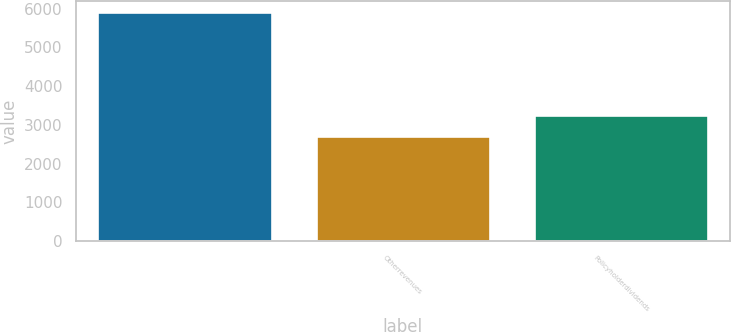<chart> <loc_0><loc_0><loc_500><loc_500><bar_chart><ecel><fcel>Otherrevenues<fcel>Policyholderdividends<nl><fcel>5912.2<fcel>2725<fcel>3256.2<nl></chart> 